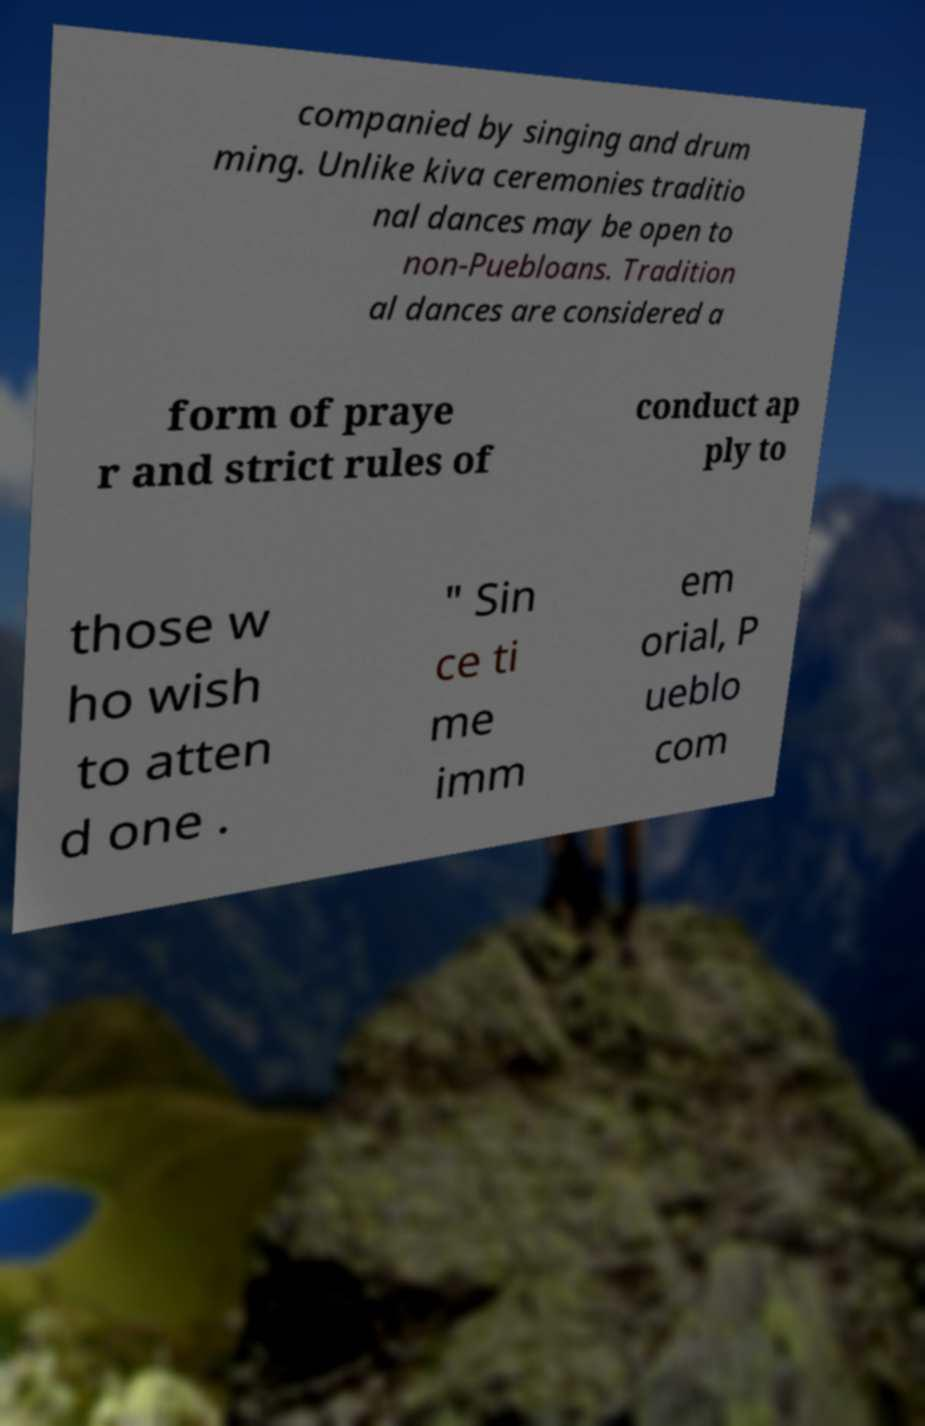Could you assist in decoding the text presented in this image and type it out clearly? companied by singing and drum ming. Unlike kiva ceremonies traditio nal dances may be open to non-Puebloans. Tradition al dances are considered a form of praye r and strict rules of conduct ap ply to those w ho wish to atten d one . " Sin ce ti me imm em orial, P ueblo com 